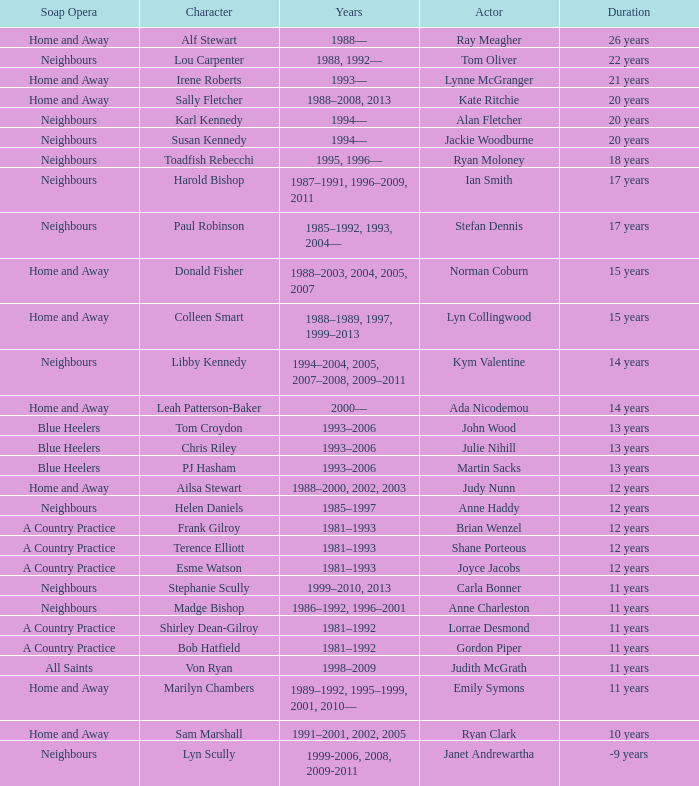Could you parse the entire table as a dict? {'header': ['Soap Opera', 'Character', 'Years', 'Actor', 'Duration'], 'rows': [['Home and Away', 'Alf Stewart', '1988—', 'Ray Meagher', '26 years'], ['Neighbours', 'Lou Carpenter', '1988, 1992—', 'Tom Oliver', '22 years'], ['Home and Away', 'Irene Roberts', '1993—', 'Lynne McGranger', '21 years'], ['Home and Away', 'Sally Fletcher', '1988–2008, 2013', 'Kate Ritchie', '20 years'], ['Neighbours', 'Karl Kennedy', '1994—', 'Alan Fletcher', '20 years'], ['Neighbours', 'Susan Kennedy', '1994—', 'Jackie Woodburne', '20 years'], ['Neighbours', 'Toadfish Rebecchi', '1995, 1996—', 'Ryan Moloney', '18 years'], ['Neighbours', 'Harold Bishop', '1987–1991, 1996–2009, 2011', 'Ian Smith', '17 years'], ['Neighbours', 'Paul Robinson', '1985–1992, 1993, 2004—', 'Stefan Dennis', '17 years'], ['Home and Away', 'Donald Fisher', '1988–2003, 2004, 2005, 2007', 'Norman Coburn', '15 years'], ['Home and Away', 'Colleen Smart', '1988–1989, 1997, 1999–2013', 'Lyn Collingwood', '15 years'], ['Neighbours', 'Libby Kennedy', '1994–2004, 2005, 2007–2008, 2009–2011', 'Kym Valentine', '14 years'], ['Home and Away', 'Leah Patterson-Baker', '2000—', 'Ada Nicodemou', '14 years'], ['Blue Heelers', 'Tom Croydon', '1993–2006', 'John Wood', '13 years'], ['Blue Heelers', 'Chris Riley', '1993–2006', 'Julie Nihill', '13 years'], ['Blue Heelers', 'PJ Hasham', '1993–2006', 'Martin Sacks', '13 years'], ['Home and Away', 'Ailsa Stewart', '1988–2000, 2002, 2003', 'Judy Nunn', '12 years'], ['Neighbours', 'Helen Daniels', '1985–1997', 'Anne Haddy', '12 years'], ['A Country Practice', 'Frank Gilroy', '1981–1993', 'Brian Wenzel', '12 years'], ['A Country Practice', 'Terence Elliott', '1981–1993', 'Shane Porteous', '12 years'], ['A Country Practice', 'Esme Watson', '1981–1993', 'Joyce Jacobs', '12 years'], ['Neighbours', 'Stephanie Scully', '1999–2010, 2013', 'Carla Bonner', '11 years'], ['Neighbours', 'Madge Bishop', '1986–1992, 1996–2001', 'Anne Charleston', '11 years'], ['A Country Practice', 'Shirley Dean-Gilroy', '1981–1992', 'Lorrae Desmond', '11 years'], ['A Country Practice', 'Bob Hatfield', '1981–1992', 'Gordon Piper', '11 years'], ['All Saints', 'Von Ryan', '1998–2009', 'Judith McGrath', '11 years'], ['Home and Away', 'Marilyn Chambers', '1989–1992, 1995–1999, 2001, 2010—', 'Emily Symons', '11 years'], ['Home and Away', 'Sam Marshall', '1991–2001, 2002, 2005', 'Ryan Clark', '10 years'], ['Neighbours', 'Lyn Scully', '1999-2006, 2008, 2009-2011', 'Janet Andrewartha', '-9 years']]} What character was portrayed by the same actor for 12 years on Neighbours? Helen Daniels. 